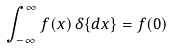<formula> <loc_0><loc_0><loc_500><loc_500>\int _ { - \infty } ^ { \infty } f ( x ) \, \delta \{ d x \} = f ( 0 )</formula> 